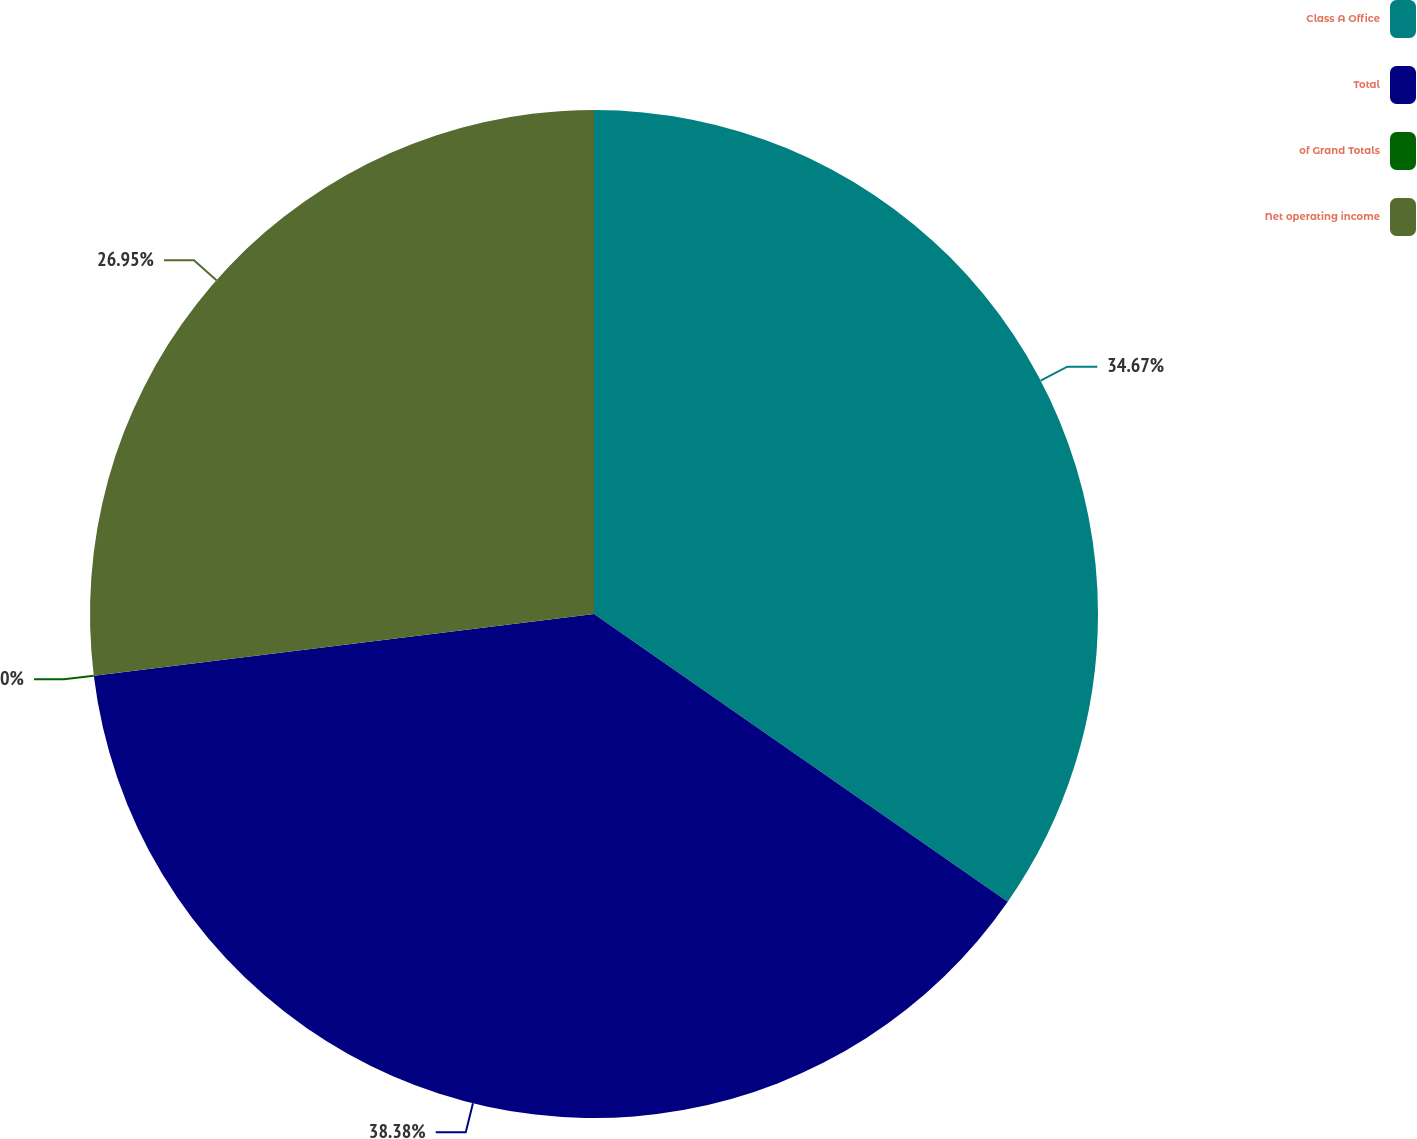Convert chart. <chart><loc_0><loc_0><loc_500><loc_500><pie_chart><fcel>Class A Office<fcel>Total<fcel>of Grand Totals<fcel>Net operating income<nl><fcel>34.67%<fcel>38.37%<fcel>0.0%<fcel>26.95%<nl></chart> 